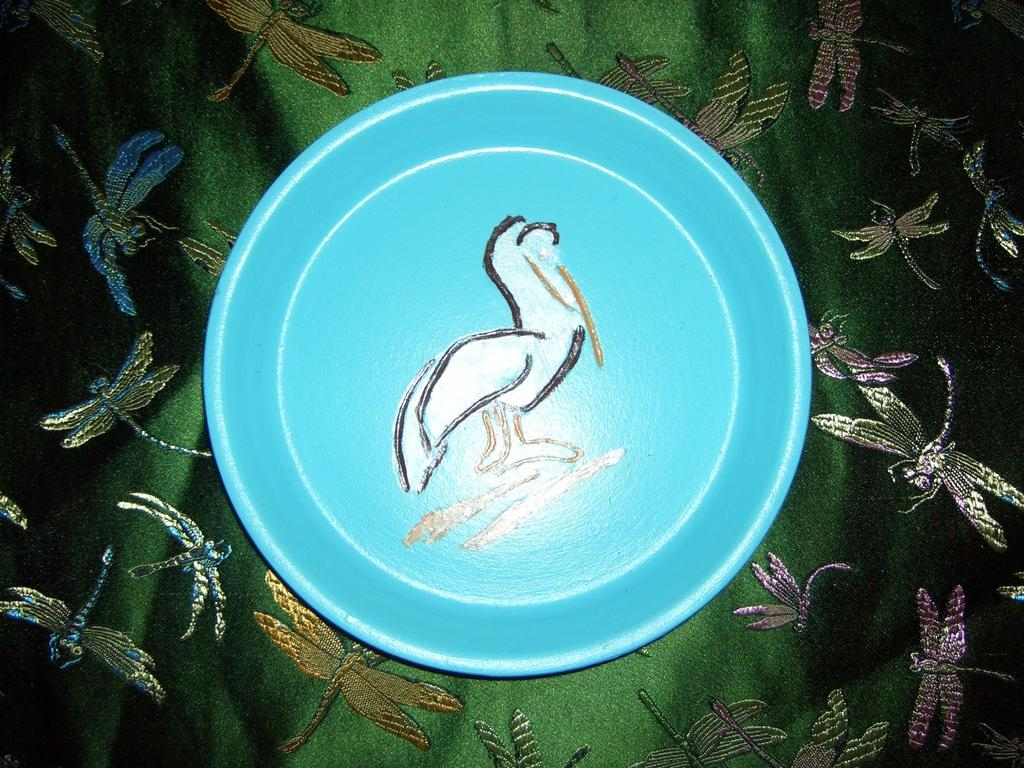What object is present on the cloth in the image? There is a plate in the image. What can be observed about the plate's appearance? The plate has a design on it. What is the plate placed on in the image? The plate is on a cloth. How many monkeys are sitting on the plate in the image? There are no monkeys present in the image; the plate has a design on it. 